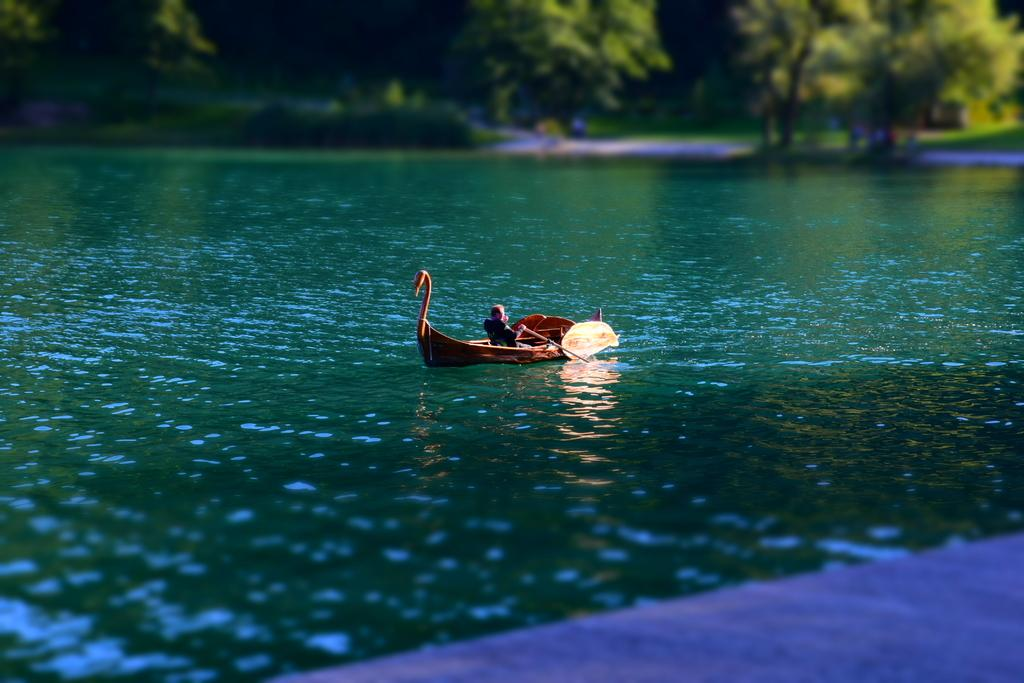What is the main subject of the image? There is a boat in the image. Who or what is on the boat? A person is sitting and riding the boat. What can be seen in the background of the image? There are trees visible in the distance. How many frogs are jumping on the boat in the image? There are no frogs present in the image; it only features a boat and a person riding it. What type of industry can be seen in the background of the image? There is no industry visible in the image; it only shows a boat, a person, and trees in the distance. 